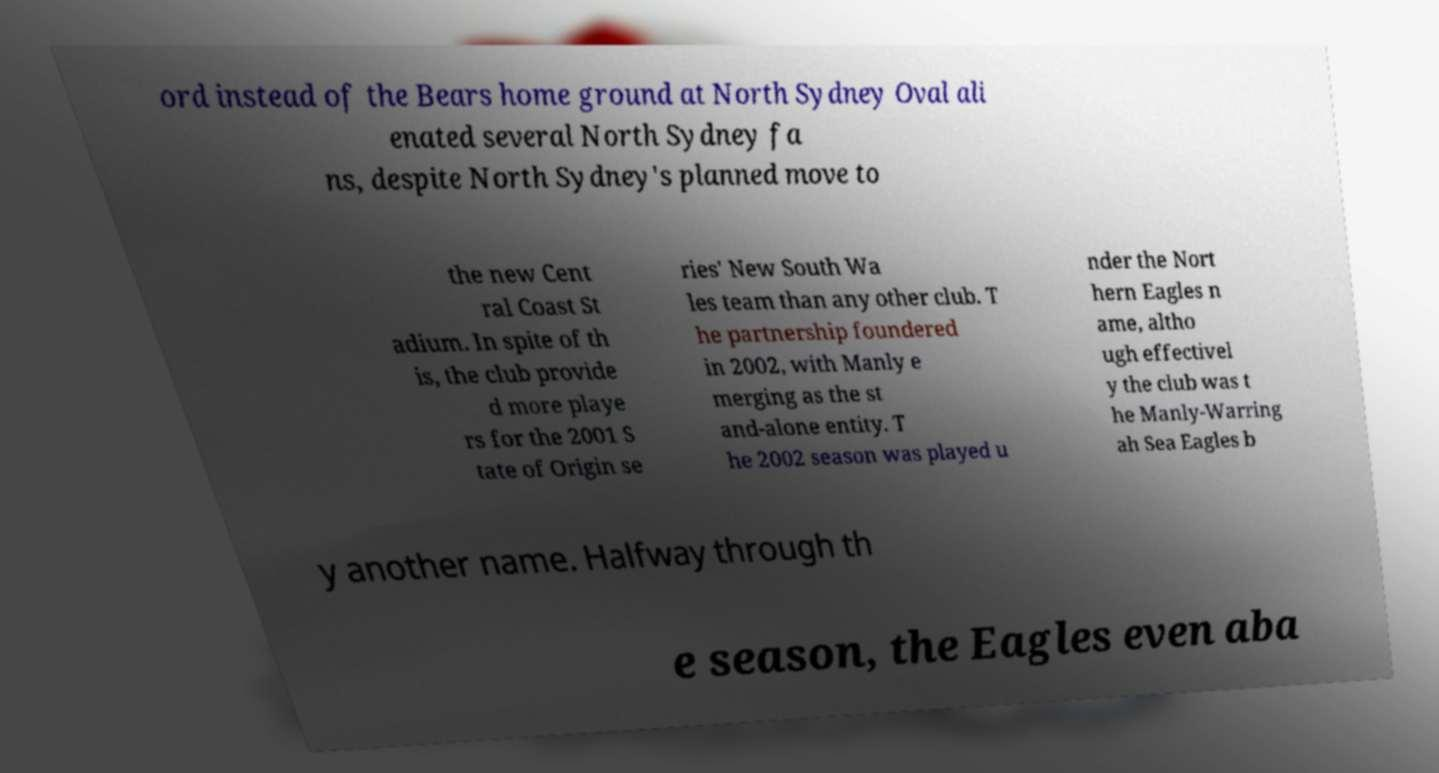Could you extract and type out the text from this image? ord instead of the Bears home ground at North Sydney Oval ali enated several North Sydney fa ns, despite North Sydney's planned move to the new Cent ral Coast St adium. In spite of th is, the club provide d more playe rs for the 2001 S tate of Origin se ries' New South Wa les team than any other club. T he partnership foundered in 2002, with Manly e merging as the st and-alone entity. T he 2002 season was played u nder the Nort hern Eagles n ame, altho ugh effectivel y the club was t he Manly-Warring ah Sea Eagles b y another name. Halfway through th e season, the Eagles even aba 